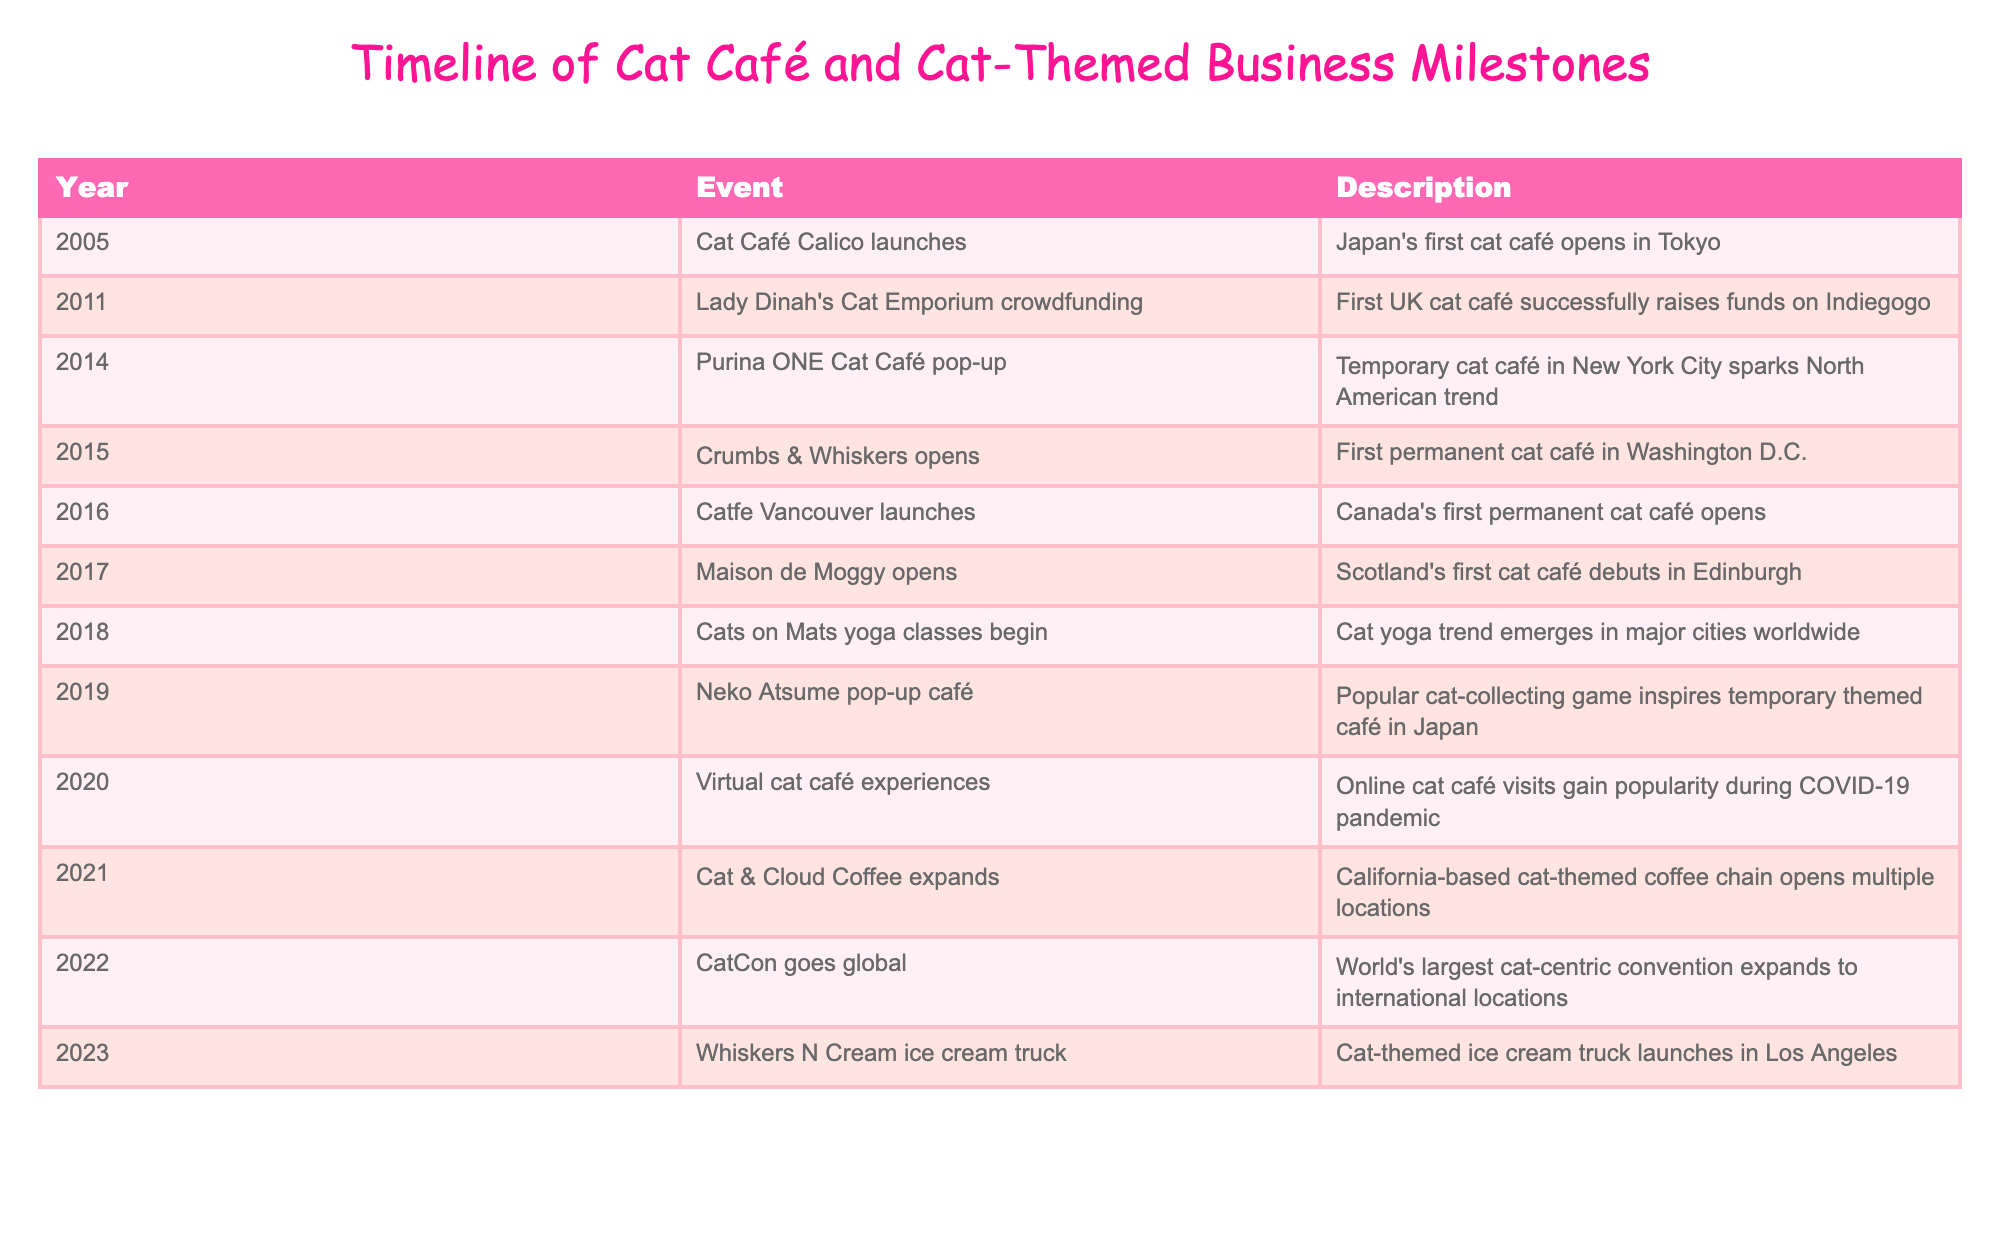What year did Japan's first cat café open? The table lists events chronologically by year. The event "Cat Café Calico launches" indicates that Japan's first cat café opened in Tokyo in 2005.
Answer: 2005 Which country saw the first permanent cat café in 2015? The event "Crumbs & Whiskers opens" mentions the first permanent cat café in Washington D.C., which is in the United States.
Answer: United States How many years passed between the opening of the first cat café in Japan and the first permanent cat café in Canada? The first cat café in Japan opened in 2005, and the first permanent cat café in Canada opened in 2016. The years between these events are 2016 - 2005 = 11 years.
Answer: 11 years Did Lady Dinah's Cat Emporium raise funds through crowdfunding? The description for the event states that "First UK cat café successfully raises funds on Indiegogo," indicating that it indeed used crowdfunding.
Answer: Yes What event marked the emergence of the cat yoga trend worldwide? The event "Cats on Mats yoga classes begin" shows that cat yoga classes started in 2018, leading to the conclusion that this was the emergence of the trend.
Answer: Cats on Mats yoga classes begin What is the maximum number of cat cafés opened in a single year based on the table data? By examining the yearly events listed, only one event occurred in each of the years 2016, 2017, and 2019. However, 2021 saw the expansion of "Cat & Cloud Coffee." Since no specific number is indicated beyond singular occurrences for specific openings, the maximum is 1 per year based on entries.
Answer: 1 How many years are between the popularization of virtual cat café experiences and the opening of the world's largest cat-centric convention? The virtual cat café experiences became popular in 2020, and CatCon went global in 2022. The difference is 2022 - 2020 = 2 years.
Answer: 2 years Was there any increase in international presence for cat-themed conventions after 2022? The table indicates that CatCon went global in 2022, suggesting an international presence was established then and does not indicate further increase.
Answer: No 